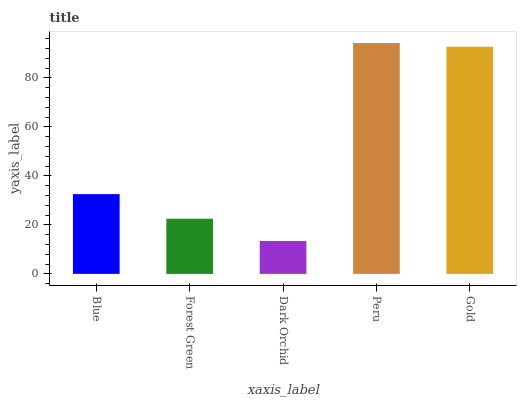Is Dark Orchid the minimum?
Answer yes or no. Yes. Is Peru the maximum?
Answer yes or no. Yes. Is Forest Green the minimum?
Answer yes or no. No. Is Forest Green the maximum?
Answer yes or no. No. Is Blue greater than Forest Green?
Answer yes or no. Yes. Is Forest Green less than Blue?
Answer yes or no. Yes. Is Forest Green greater than Blue?
Answer yes or no. No. Is Blue less than Forest Green?
Answer yes or no. No. Is Blue the high median?
Answer yes or no. Yes. Is Blue the low median?
Answer yes or no. Yes. Is Peru the high median?
Answer yes or no. No. Is Gold the low median?
Answer yes or no. No. 